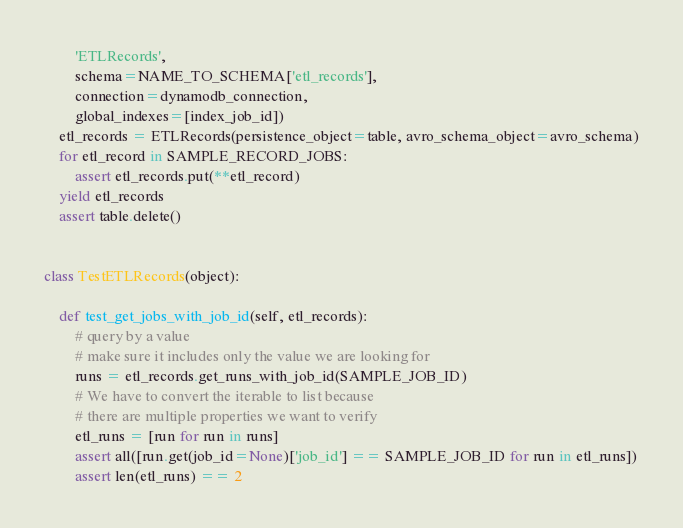<code> <loc_0><loc_0><loc_500><loc_500><_Python_>        'ETLRecords',
        schema=NAME_TO_SCHEMA['etl_records'],
        connection=dynamodb_connection,
        global_indexes=[index_job_id])
    etl_records = ETLRecords(persistence_object=table, avro_schema_object=avro_schema)
    for etl_record in SAMPLE_RECORD_JOBS:
        assert etl_records.put(**etl_record)
    yield etl_records
    assert table.delete()


class TestETLRecords(object):

    def test_get_jobs_with_job_id(self, etl_records):
        # query by a value
        # make sure it includes only the value we are looking for
        runs = etl_records.get_runs_with_job_id(SAMPLE_JOB_ID)
        # We have to convert the iterable to list because
        # there are multiple properties we want to verify
        etl_runs = [run for run in runs]
        assert all([run.get(job_id=None)['job_id'] == SAMPLE_JOB_ID for run in etl_runs])
        assert len(etl_runs) == 2
</code> 